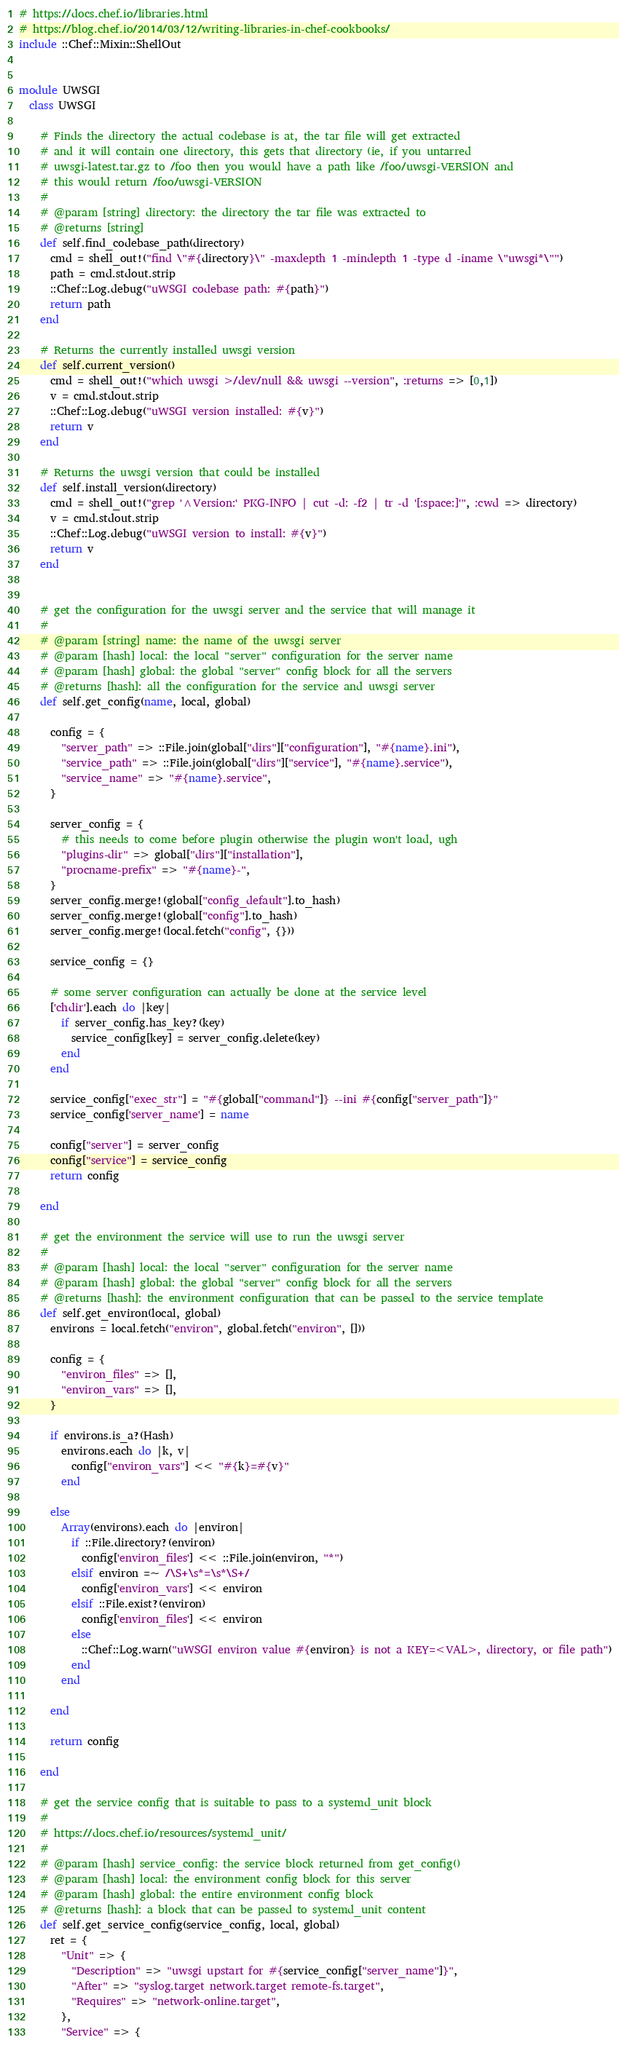Convert code to text. <code><loc_0><loc_0><loc_500><loc_500><_Ruby_># https://docs.chef.io/libraries.html
# https://blog.chef.io/2014/03/12/writing-libraries-in-chef-cookbooks/
include ::Chef::Mixin::ShellOut


module UWSGI
  class UWSGI

    # Finds the directory the actual codebase is at, the tar file will get extracted
    # and it will contain one directory, this gets that directory (ie, if you untarred
    # uwsgi-latest.tar.gz to /foo then you would have a path like /foo/uwsgi-VERSION and
    # this would return /foo/uwsgi-VERSION
    #
    # @param [string] directory: the directory the tar file was extracted to
    # @returns [string] 
    def self.find_codebase_path(directory)
      cmd = shell_out!("find \"#{directory}\" -maxdepth 1 -mindepth 1 -type d -iname \"uwsgi*\"")
      path = cmd.stdout.strip
      ::Chef::Log.debug("uWSGI codebase path: #{path}")
      return path
    end

    # Returns the currently installed uwsgi version
    def self.current_version()
      cmd = shell_out!("which uwsgi >/dev/null && uwsgi --version", :returns => [0,1])
      v = cmd.stdout.strip
      ::Chef::Log.debug("uWSGI version installed: #{v}")
      return v
    end

    # Returns the uwsgi version that could be installed
    def self.install_version(directory)
      cmd = shell_out!("grep '^Version:' PKG-INFO | cut -d: -f2 | tr -d '[:space:]'", :cwd => directory)
      v = cmd.stdout.strip
      ::Chef::Log.debug("uWSGI version to install: #{v}")
      return v
    end


    # get the configuration for the uwsgi server and the service that will manage it
    #
    # @param [string] name: the name of the uwsgi server
    # @param [hash] local: the local "server" configuration for the server name
    # @param [hash] global: the global "server" config block for all the servers
    # @returns [hash]: all the configuration for the service and uwsgi server
    def self.get_config(name, local, global)

      config = {
        "server_path" => ::File.join(global["dirs"]["configuration"], "#{name}.ini"),
        "service_path" => ::File.join(global["dirs"]["service"], "#{name}.service"),
        "service_name" => "#{name}.service",
      }

      server_config = {
        # this needs to come before plugin otherwise the plugin won't load, ugh
        "plugins-dir" => global["dirs"]["installation"],
        "procname-prefix" => "#{name}-",
      }
      server_config.merge!(global["config_default"].to_hash)
      server_config.merge!(global["config"].to_hash)
      server_config.merge!(local.fetch("config", {}))

      service_config = {}

      # some server configuration can actually be done at the service level
      ['chdir'].each do |key|
        if server_config.has_key?(key)
          service_config[key] = server_config.delete(key)
        end
      end

      service_config["exec_str"] = "#{global["command"]} --ini #{config["server_path"]}"
      service_config['server_name'] = name

      config["server"] = server_config
      config["service"] = service_config
      return config

    end

    # get the environment the service will use to run the uwsgi server
    #
    # @param [hash] local: the local "server" configuration for the server name
    # @param [hash] global: the global "server" config block for all the servers
    # @returns [hash]: the environment configuration that can be passed to the service template
    def self.get_environ(local, global)
      environs = local.fetch("environ", global.fetch("environ", []))

      config = {
        "environ_files" => [],
        "environ_vars" => [],
      }

      if environs.is_a?(Hash)
        environs.each do |k, v|
          config["environ_vars"] << "#{k}=#{v}"
        end

      else
        Array(environs).each do |environ|
          if ::File.directory?(environ)
            config['environ_files'] << ::File.join(environ, "*")
          elsif environ =~ /\S+\s*=\s*\S+/
            config['environ_vars'] << environ
          elsif ::File.exist?(environ)
            config['environ_files'] << environ
          else
            ::Chef::Log.warn("uWSGI environ value #{environ} is not a KEY=<VAL>, directory, or file path")
          end
        end

      end

      return config

    end

    # get the service config that is suitable to pass to a systemd_unit block
    #
    # https://docs.chef.io/resources/systemd_unit/
    #
    # @param [hash] service_config: the service block returned from get_config()
    # @param [hash] local: the environment config block for this server
    # @param [hash] global: the entire environment config block
    # @returns [hash]: a block that can be passed to systemd_unit content
    def self.get_service_config(service_config, local, global)
      ret = {
        "Unit" => {
          "Description" => "uwsgi upstart for #{service_config["server_name"]}",
          "After" => "syslog.target network.target remote-fs.target",
          "Requires" => "network-online.target",
        },
        "Service" => {</code> 